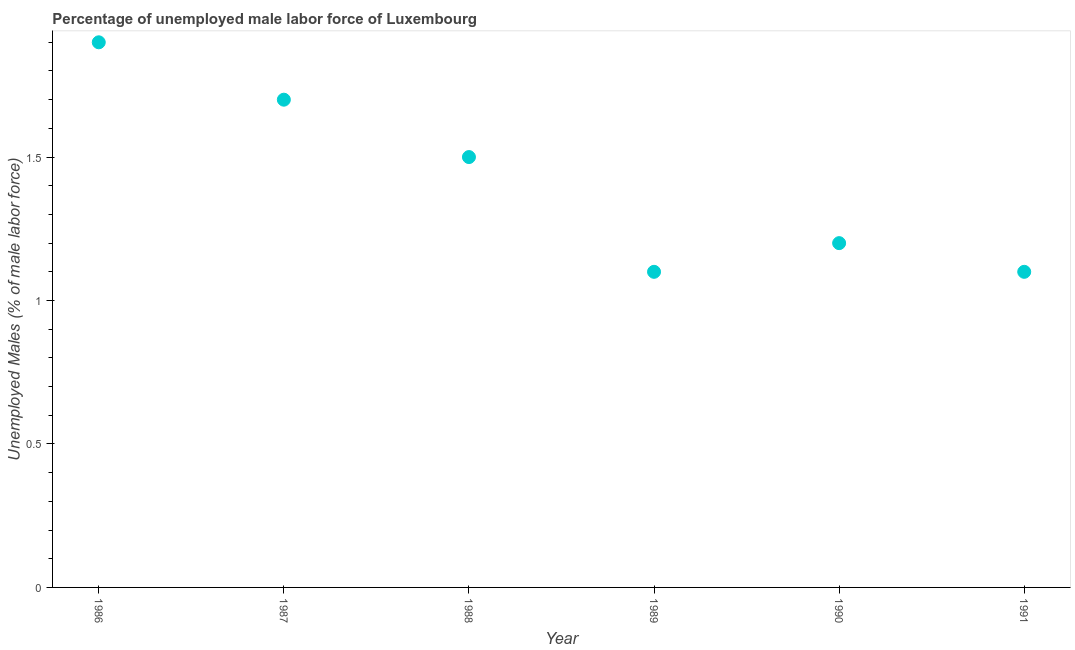What is the total unemployed male labour force in 1990?
Offer a very short reply. 1.2. Across all years, what is the maximum total unemployed male labour force?
Offer a very short reply. 1.9. Across all years, what is the minimum total unemployed male labour force?
Your answer should be compact. 1.1. In which year was the total unemployed male labour force maximum?
Keep it short and to the point. 1986. In which year was the total unemployed male labour force minimum?
Give a very brief answer. 1989. What is the sum of the total unemployed male labour force?
Make the answer very short. 8.5. What is the difference between the total unemployed male labour force in 1987 and 1988?
Provide a short and direct response. 0.2. What is the average total unemployed male labour force per year?
Give a very brief answer. 1.42. What is the median total unemployed male labour force?
Offer a terse response. 1.35. In how many years, is the total unemployed male labour force greater than 1 %?
Your answer should be compact. 6. Do a majority of the years between 1988 and 1989 (inclusive) have total unemployed male labour force greater than 1.5 %?
Offer a very short reply. No. Is the total unemployed male labour force in 1986 less than that in 1987?
Keep it short and to the point. No. Is the difference between the total unemployed male labour force in 1986 and 1991 greater than the difference between any two years?
Provide a short and direct response. Yes. What is the difference between the highest and the second highest total unemployed male labour force?
Keep it short and to the point. 0.2. What is the difference between the highest and the lowest total unemployed male labour force?
Offer a very short reply. 0.8. In how many years, is the total unemployed male labour force greater than the average total unemployed male labour force taken over all years?
Your response must be concise. 3. Does the total unemployed male labour force monotonically increase over the years?
Provide a short and direct response. No. Does the graph contain any zero values?
Your answer should be very brief. No. What is the title of the graph?
Your response must be concise. Percentage of unemployed male labor force of Luxembourg. What is the label or title of the Y-axis?
Make the answer very short. Unemployed Males (% of male labor force). What is the Unemployed Males (% of male labor force) in 1986?
Keep it short and to the point. 1.9. What is the Unemployed Males (% of male labor force) in 1987?
Ensure brevity in your answer.  1.7. What is the Unemployed Males (% of male labor force) in 1988?
Make the answer very short. 1.5. What is the Unemployed Males (% of male labor force) in 1989?
Keep it short and to the point. 1.1. What is the Unemployed Males (% of male labor force) in 1990?
Provide a succinct answer. 1.2. What is the Unemployed Males (% of male labor force) in 1991?
Your answer should be very brief. 1.1. What is the difference between the Unemployed Males (% of male labor force) in 1986 and 1988?
Offer a very short reply. 0.4. What is the difference between the Unemployed Males (% of male labor force) in 1986 and 1989?
Your answer should be compact. 0.8. What is the difference between the Unemployed Males (% of male labor force) in 1986 and 1991?
Your answer should be very brief. 0.8. What is the difference between the Unemployed Males (% of male labor force) in 1987 and 1989?
Make the answer very short. 0.6. What is the difference between the Unemployed Males (% of male labor force) in 1987 and 1990?
Provide a short and direct response. 0.5. What is the difference between the Unemployed Males (% of male labor force) in 1987 and 1991?
Make the answer very short. 0.6. What is the difference between the Unemployed Males (% of male labor force) in 1988 and 1989?
Provide a short and direct response. 0.4. What is the difference between the Unemployed Males (% of male labor force) in 1989 and 1991?
Your response must be concise. 0. What is the ratio of the Unemployed Males (% of male labor force) in 1986 to that in 1987?
Give a very brief answer. 1.12. What is the ratio of the Unemployed Males (% of male labor force) in 1986 to that in 1988?
Your answer should be very brief. 1.27. What is the ratio of the Unemployed Males (% of male labor force) in 1986 to that in 1989?
Keep it short and to the point. 1.73. What is the ratio of the Unemployed Males (% of male labor force) in 1986 to that in 1990?
Your response must be concise. 1.58. What is the ratio of the Unemployed Males (% of male labor force) in 1986 to that in 1991?
Offer a terse response. 1.73. What is the ratio of the Unemployed Males (% of male labor force) in 1987 to that in 1988?
Provide a short and direct response. 1.13. What is the ratio of the Unemployed Males (% of male labor force) in 1987 to that in 1989?
Provide a succinct answer. 1.54. What is the ratio of the Unemployed Males (% of male labor force) in 1987 to that in 1990?
Provide a short and direct response. 1.42. What is the ratio of the Unemployed Males (% of male labor force) in 1987 to that in 1991?
Provide a short and direct response. 1.54. What is the ratio of the Unemployed Males (% of male labor force) in 1988 to that in 1989?
Provide a succinct answer. 1.36. What is the ratio of the Unemployed Males (% of male labor force) in 1988 to that in 1991?
Offer a very short reply. 1.36. What is the ratio of the Unemployed Males (% of male labor force) in 1989 to that in 1990?
Ensure brevity in your answer.  0.92. What is the ratio of the Unemployed Males (% of male labor force) in 1989 to that in 1991?
Provide a short and direct response. 1. What is the ratio of the Unemployed Males (% of male labor force) in 1990 to that in 1991?
Provide a succinct answer. 1.09. 